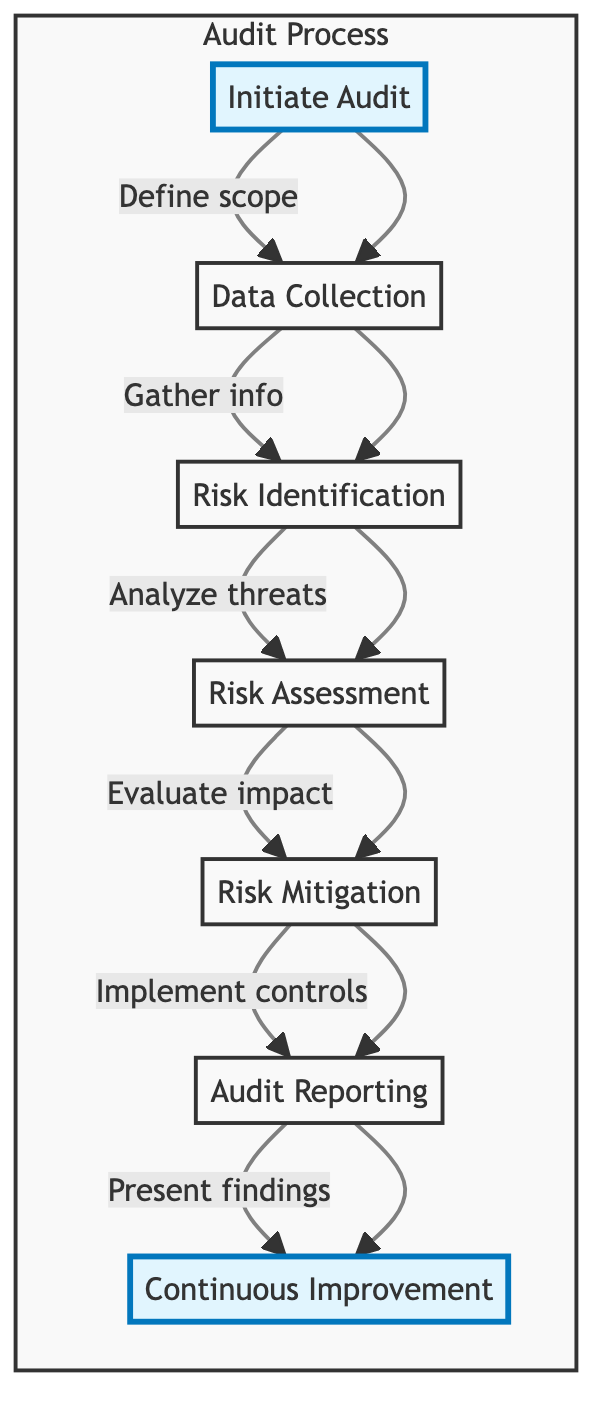What is the first step in the cybersecurity audit process? The diagram shows "Initiate Audit" as the first node, indicating this is the first step in the process.
Answer: Initiate Audit How many main nodes are there in the flowchart? Counting each of the distinct nodes in the flowchart (from Initiate Audit to Continuous Improvement), we find there are six main nodes connected in a sequence.
Answer: Six What follows after "Data Collection"? The diagram indicates that the next node in the sequence after "Data Collection" is "Risk Identification."
Answer: Risk Identification Which step involves determining risk likelihood? Referring to the "Risk Assessment" node, it is specified that one of the activities is to "Determine risk likelihood," indicating this step covers it.
Answer: Risk Assessment Which two steps are highlighted in the flowchart? Looking at the visual properties set in the diagram, "Initiate Audit" and "Continuous Improvement" are marked with a special highlight style.
Answer: Initiate Audit, Continuous Improvement What is the final step in the audit process? The last node in the sequence of the flowchart is "Continuous Improvement," which indicates it is the final step of the process.
Answer: Continuous Improvement Which activity comes before "Audit Reporting"? The flowchart indicates that "Risk Mitigation" is the step immediately preceding "Audit Reporting."
Answer: Risk Mitigation What types of activities are included in "Risk Identification"? The description under "Risk Identification" specifies that activities like "Conduct vulnerability assessments" are part of this step, highlighting the focus on assessing potential risks.
Answer: Conduct vulnerability assessments, Analyze threat intelligence reports, Identify critical assets, Map risk scenarios Which step focuses on improving cybersecurity strategy based on previous audits? The step "Continuous Improvement" pertains specifically to enhancing the cybersecurity strategy through regular reviews and updates post-audit, as indicated in the diagram.
Answer: Continuous Improvement 